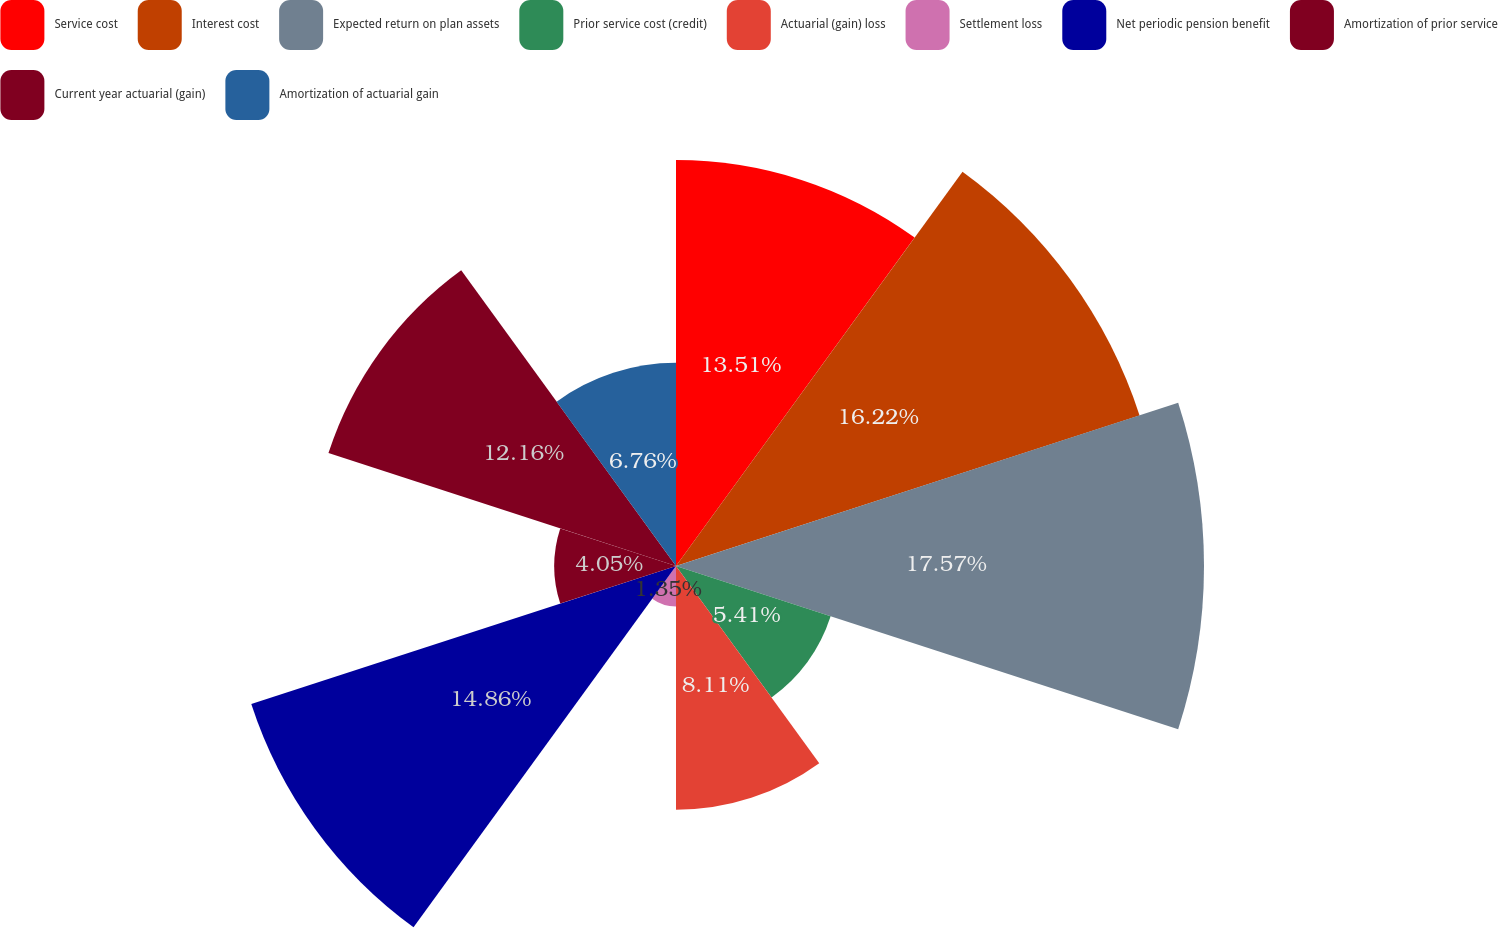Convert chart to OTSL. <chart><loc_0><loc_0><loc_500><loc_500><pie_chart><fcel>Service cost<fcel>Interest cost<fcel>Expected return on plan assets<fcel>Prior service cost (credit)<fcel>Actuarial (gain) loss<fcel>Settlement loss<fcel>Net periodic pension benefit<fcel>Amortization of prior service<fcel>Current year actuarial (gain)<fcel>Amortization of actuarial gain<nl><fcel>13.51%<fcel>16.22%<fcel>17.57%<fcel>5.41%<fcel>8.11%<fcel>1.35%<fcel>14.86%<fcel>4.05%<fcel>12.16%<fcel>6.76%<nl></chart> 